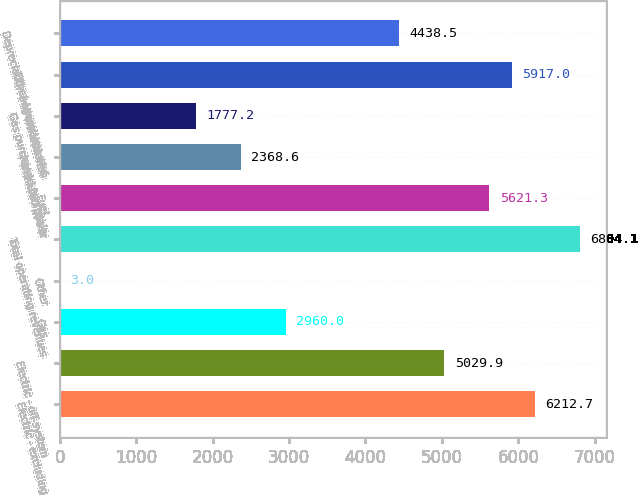Convert chart to OTSL. <chart><loc_0><loc_0><loc_500><loc_500><bar_chart><fcel>Electric - excluding<fcel>Electric - off-system<fcel>Gas<fcel>Other<fcel>Total operating revenues<fcel>Fuel<fcel>Purchased power<fcel>Gas purchased for resale<fcel>Other operations and<fcel>Depreciation and amortization<nl><fcel>6212.7<fcel>5029.9<fcel>2960<fcel>3<fcel>6804.1<fcel>5621.3<fcel>2368.6<fcel>1777.2<fcel>5917<fcel>4438.5<nl></chart> 